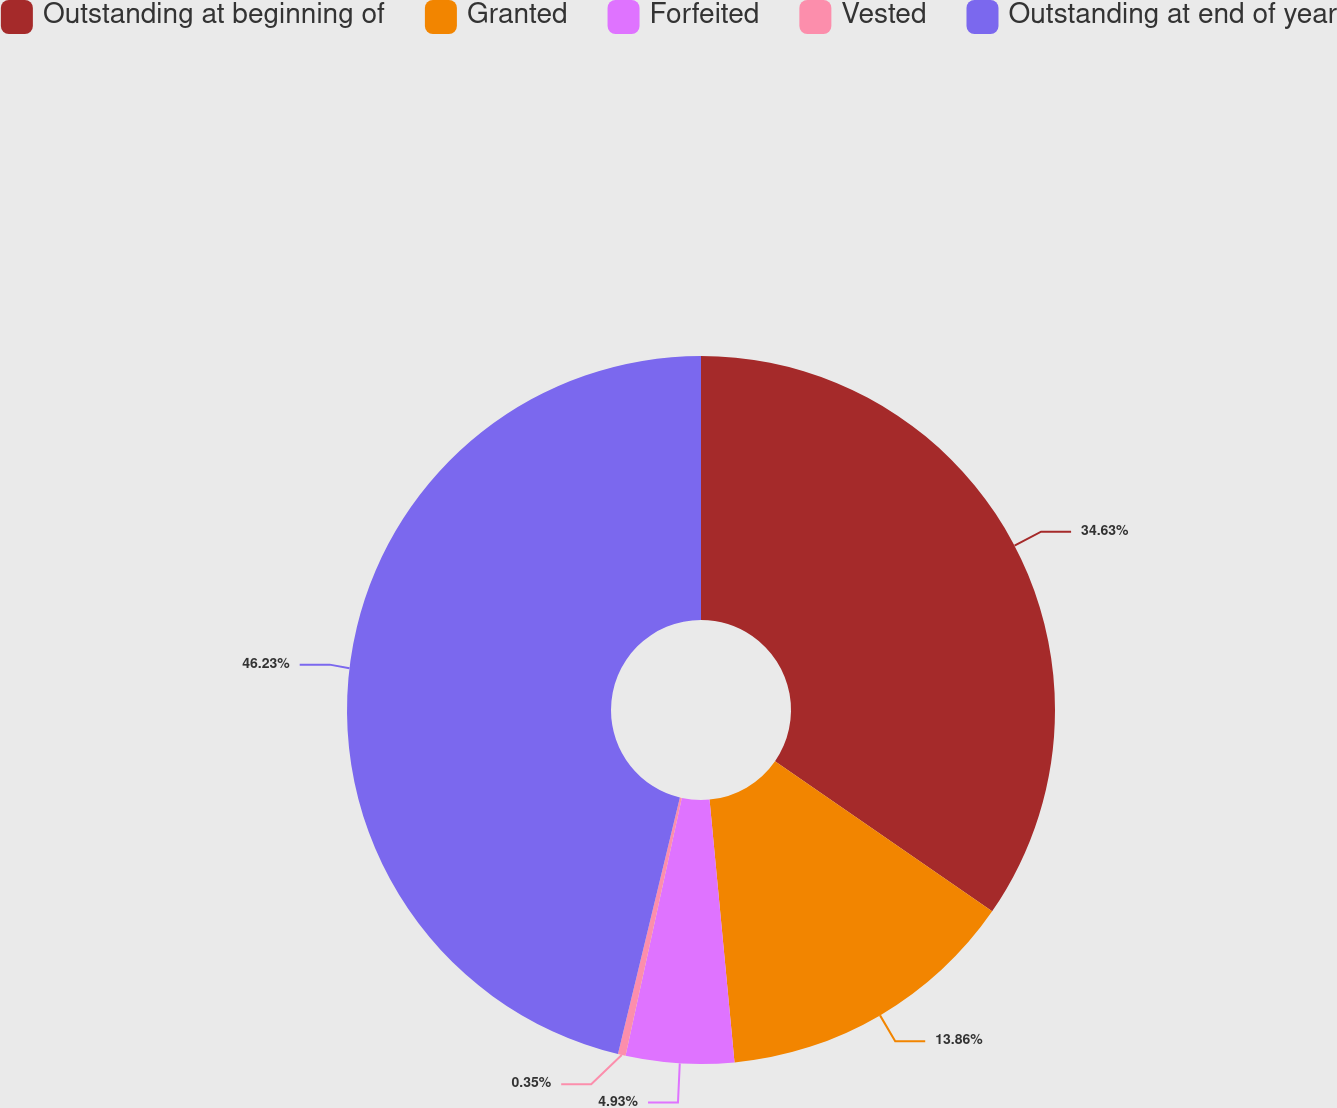Convert chart to OTSL. <chart><loc_0><loc_0><loc_500><loc_500><pie_chart><fcel>Outstanding at beginning of<fcel>Granted<fcel>Forfeited<fcel>Vested<fcel>Outstanding at end of year<nl><fcel>34.63%<fcel>13.86%<fcel>4.93%<fcel>0.35%<fcel>46.23%<nl></chart> 